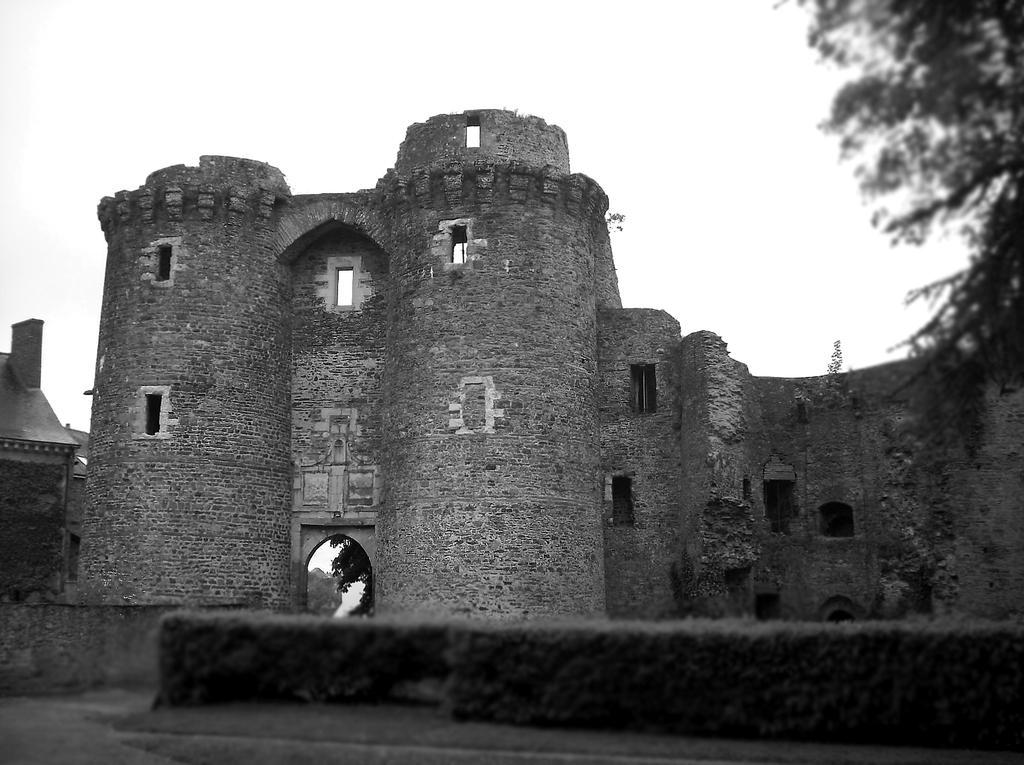In one or two sentences, can you explain what this image depicts? In the center of the image we can see a fort. On the right there is a tree. In the background there is sky. 